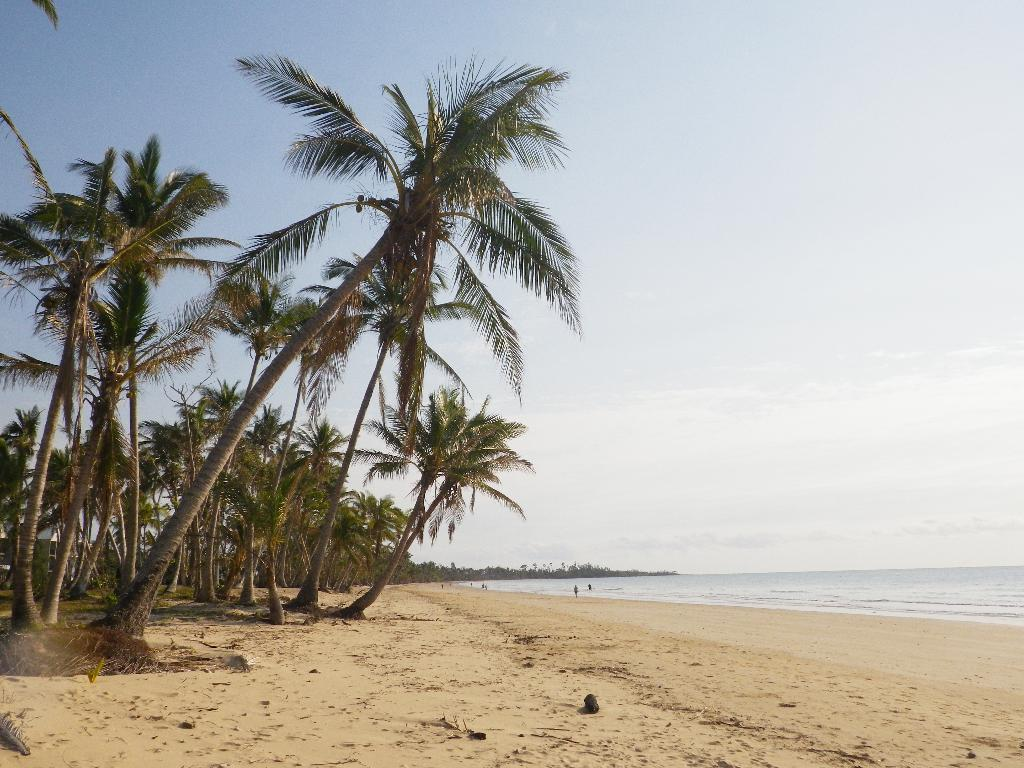What type of vegetation can be seen in the image? There are trees in the image. What type of terrain is visible in the image? There is sand in the image. What natural element is present in the image? There is water in the image. How would you describe the color of the sky in the image? The sky is white and blue in color. How many eyes can be seen in the image? There are no eyes present in the image. Is there a crowd visible in the image? There is no crowd present in the image. 